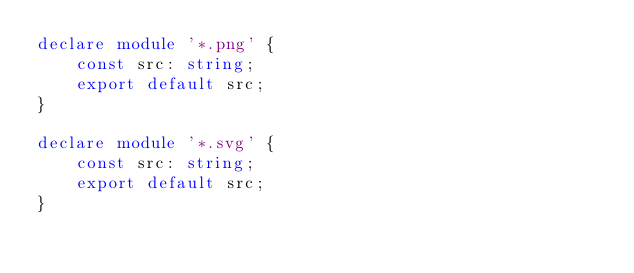<code> <loc_0><loc_0><loc_500><loc_500><_TypeScript_>declare module '*.png' {
	const src: string;
	export default src;
}

declare module '*.svg' {
	const src: string;
	export default src;
}</code> 